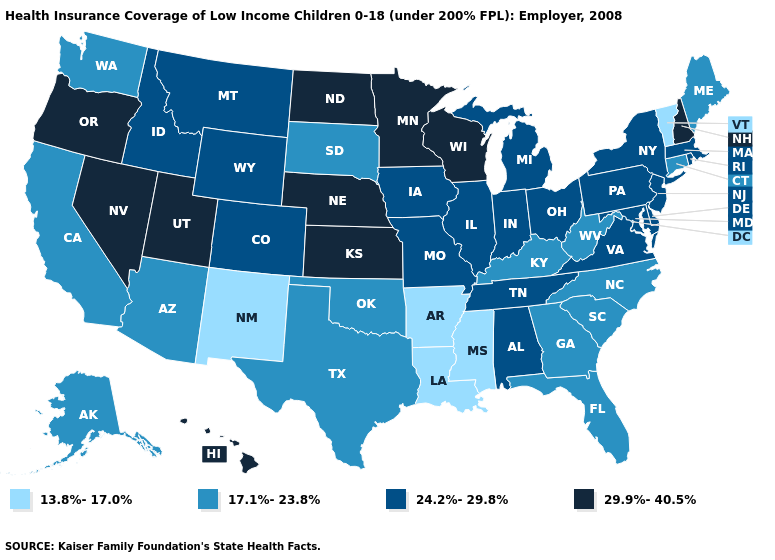What is the value of Colorado?
Short answer required. 24.2%-29.8%. Does Wisconsin have the highest value in the USA?
Concise answer only. Yes. Name the states that have a value in the range 24.2%-29.8%?
Write a very short answer. Alabama, Colorado, Delaware, Idaho, Illinois, Indiana, Iowa, Maryland, Massachusetts, Michigan, Missouri, Montana, New Jersey, New York, Ohio, Pennsylvania, Rhode Island, Tennessee, Virginia, Wyoming. What is the highest value in states that border Virginia?
Keep it brief. 24.2%-29.8%. Name the states that have a value in the range 17.1%-23.8%?
Concise answer only. Alaska, Arizona, California, Connecticut, Florida, Georgia, Kentucky, Maine, North Carolina, Oklahoma, South Carolina, South Dakota, Texas, Washington, West Virginia. Does Alabama have the same value as Alaska?
Write a very short answer. No. Name the states that have a value in the range 24.2%-29.8%?
Give a very brief answer. Alabama, Colorado, Delaware, Idaho, Illinois, Indiana, Iowa, Maryland, Massachusetts, Michigan, Missouri, Montana, New Jersey, New York, Ohio, Pennsylvania, Rhode Island, Tennessee, Virginia, Wyoming. Is the legend a continuous bar?
Give a very brief answer. No. Among the states that border Arizona , does Utah have the highest value?
Short answer required. Yes. Does the first symbol in the legend represent the smallest category?
Concise answer only. Yes. Name the states that have a value in the range 24.2%-29.8%?
Concise answer only. Alabama, Colorado, Delaware, Idaho, Illinois, Indiana, Iowa, Maryland, Massachusetts, Michigan, Missouri, Montana, New Jersey, New York, Ohio, Pennsylvania, Rhode Island, Tennessee, Virginia, Wyoming. What is the value of Rhode Island?
Give a very brief answer. 24.2%-29.8%. Which states hav the highest value in the Northeast?
Short answer required. New Hampshire. Does Delaware have the lowest value in the USA?
Concise answer only. No. Which states have the highest value in the USA?
Concise answer only. Hawaii, Kansas, Minnesota, Nebraska, Nevada, New Hampshire, North Dakota, Oregon, Utah, Wisconsin. 